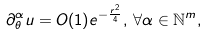Convert formula to latex. <formula><loc_0><loc_0><loc_500><loc_500>\partial _ { \theta } ^ { \alpha } u = O ( 1 ) e ^ { - \frac { r ^ { 2 } } { 4 } } , \, \forall \alpha \in \mathbb { N } ^ { m } ,</formula> 